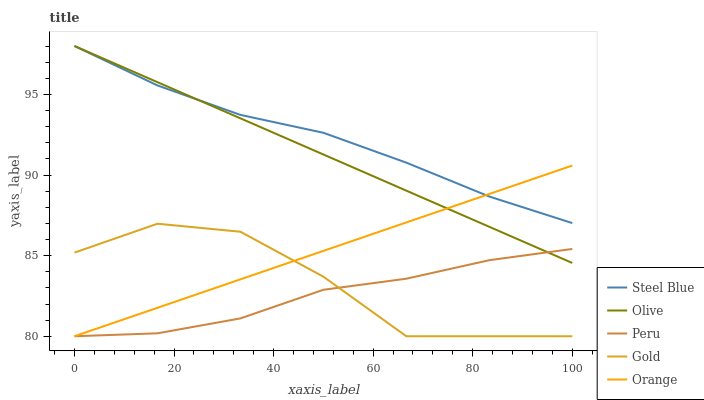Does Peru have the minimum area under the curve?
Answer yes or no. Yes. Does Steel Blue have the maximum area under the curve?
Answer yes or no. Yes. Does Gold have the minimum area under the curve?
Answer yes or no. No. Does Gold have the maximum area under the curve?
Answer yes or no. No. Is Orange the smoothest?
Answer yes or no. Yes. Is Gold the roughest?
Answer yes or no. Yes. Is Gold the smoothest?
Answer yes or no. No. Is Orange the roughest?
Answer yes or no. No. Does Gold have the lowest value?
Answer yes or no. Yes. Does Steel Blue have the lowest value?
Answer yes or no. No. Does Steel Blue have the highest value?
Answer yes or no. Yes. Does Gold have the highest value?
Answer yes or no. No. Is Gold less than Steel Blue?
Answer yes or no. Yes. Is Olive greater than Gold?
Answer yes or no. Yes. Does Peru intersect Gold?
Answer yes or no. Yes. Is Peru less than Gold?
Answer yes or no. No. Is Peru greater than Gold?
Answer yes or no. No. Does Gold intersect Steel Blue?
Answer yes or no. No. 